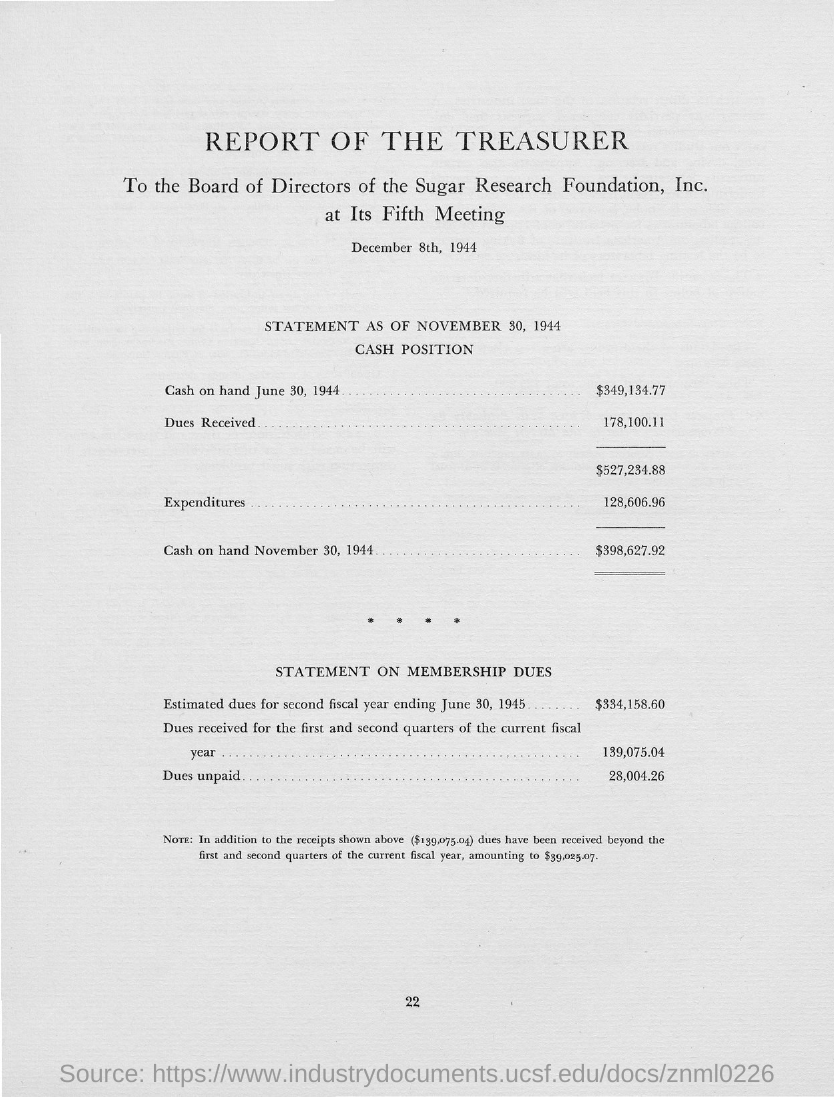Point out several critical features in this image. During the first and second quarters of the current fiscal year, a total of 139,075.04 dollars in dues have been received. The estimated dues for the second fiscal year ending on June 30, 1945, were 334,158.60. 